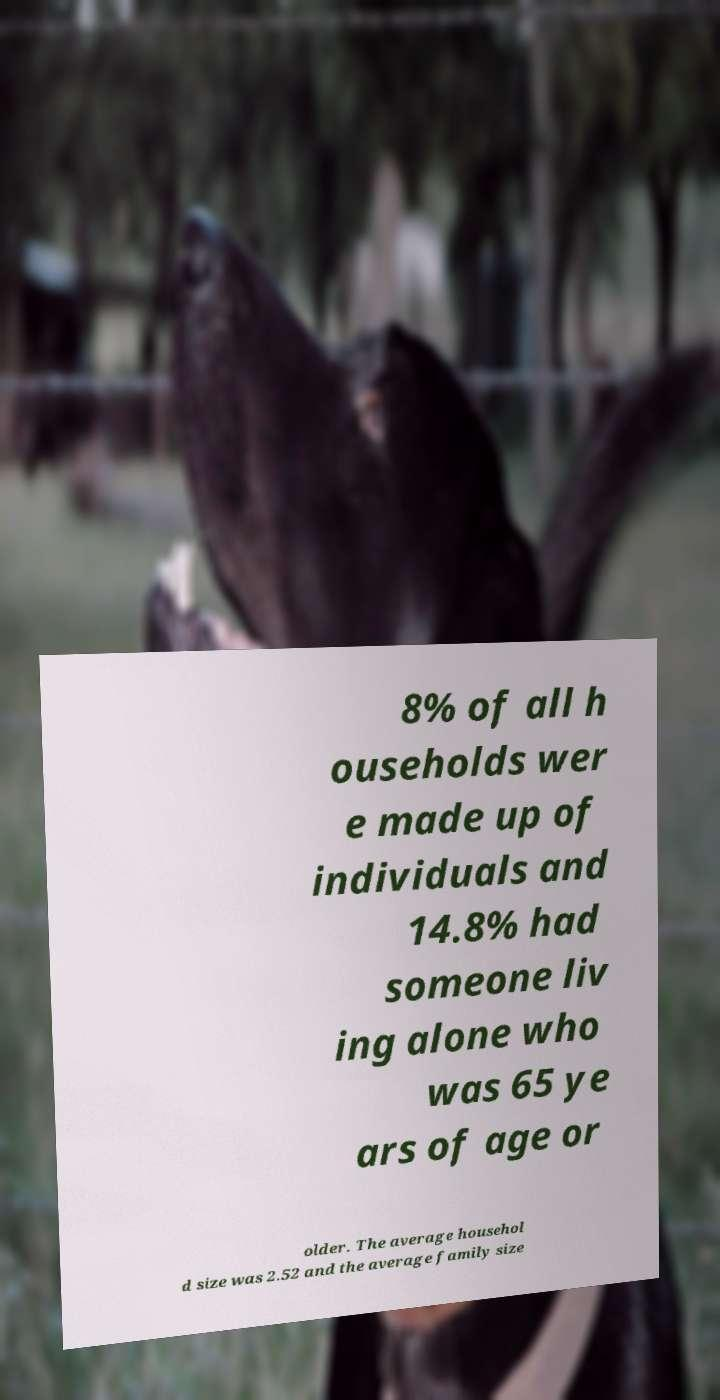Please read and relay the text visible in this image. What does it say? 8% of all h ouseholds wer e made up of individuals and 14.8% had someone liv ing alone who was 65 ye ars of age or older. The average househol d size was 2.52 and the average family size 